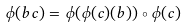<formula> <loc_0><loc_0><loc_500><loc_500>\phi ( b c ) = \phi ( \phi ( c ) ( b ) ) \circ \phi ( c )</formula> 